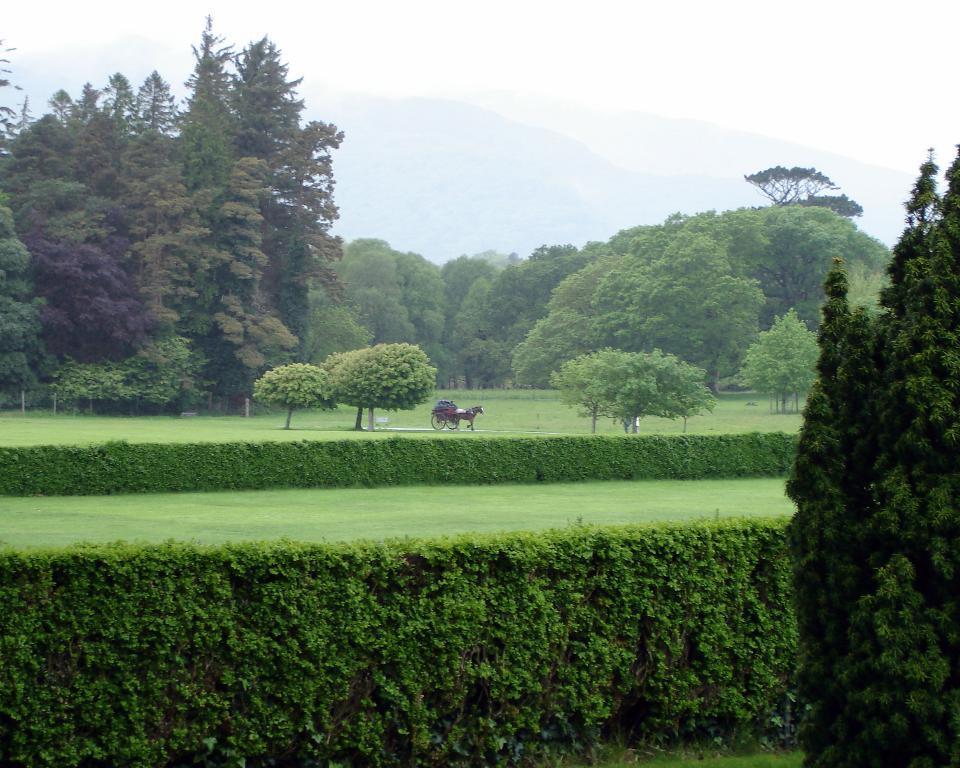How would you summarize this image in a sentence or two? In this image in the center there is a vehicle and horse, and also there are some plants, grass, trees. And in the background there are trees and mountains. 